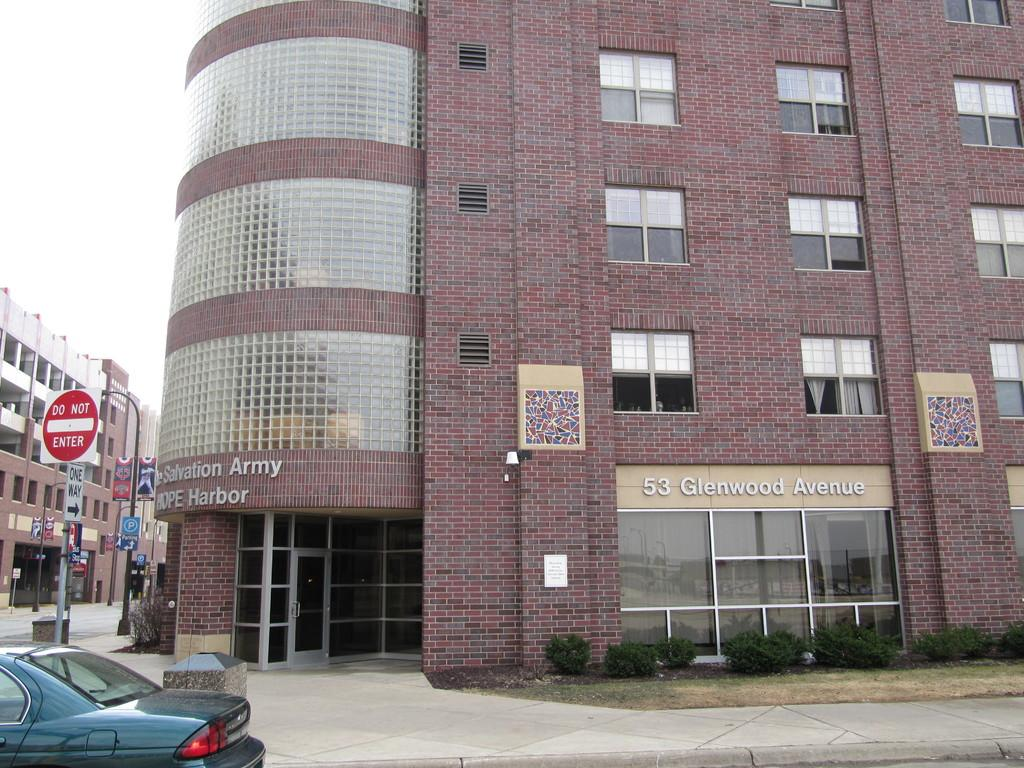What type of surface can be seen in the image? Ground is visible in the image. What is located on the ground in the image? There is a car on the ground. What structures can be seen in the image besides the car? There are poles, boards, plants, and buildings in the image. What part of the natural environment is visible in the image? Plants are visible in the image. What is visible in the background of the image? The sky is visible in the background of the image. What type of writing can be seen on the car's knee in the image? There is no writing on the car's knee, as cars do not have knees. Additionally, there is no writing visible on the car in the image. 